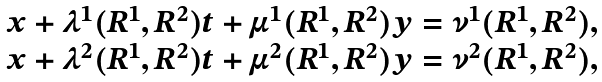Convert formula to latex. <formula><loc_0><loc_0><loc_500><loc_500>\begin{array} { c } x + \lambda ^ { 1 } ( R ^ { 1 } , R ^ { 2 } ) t + \mu ^ { 1 } ( R ^ { 1 } , R ^ { 2 } ) y = \nu ^ { 1 } ( R ^ { 1 } , R ^ { 2 } ) , \\ x + \lambda ^ { 2 } ( R ^ { 1 } , R ^ { 2 } ) t + \mu ^ { 2 } ( R ^ { 1 } , R ^ { 2 } ) y = \nu ^ { 2 } ( R ^ { 1 } , R ^ { 2 } ) , \\ \end{array}</formula> 